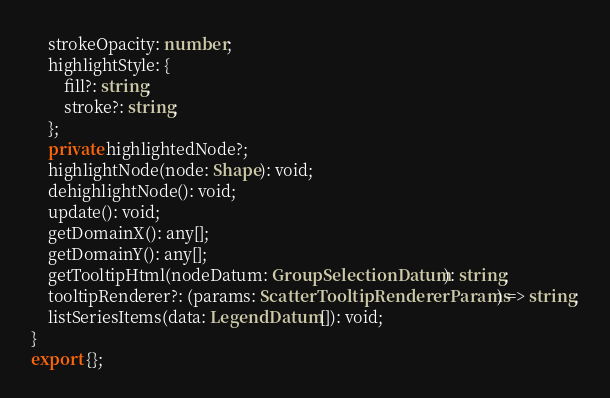Convert code to text. <code><loc_0><loc_0><loc_500><loc_500><_TypeScript_>    strokeOpacity: number;
    highlightStyle: {
        fill?: string;
        stroke?: string;
    };
    private highlightedNode?;
    highlightNode(node: Shape): void;
    dehighlightNode(): void;
    update(): void;
    getDomainX(): any[];
    getDomainY(): any[];
    getTooltipHtml(nodeDatum: GroupSelectionDatum): string;
    tooltipRenderer?: (params: ScatterTooltipRendererParams) => string;
    listSeriesItems(data: LegendDatum[]): void;
}
export {};
</code> 